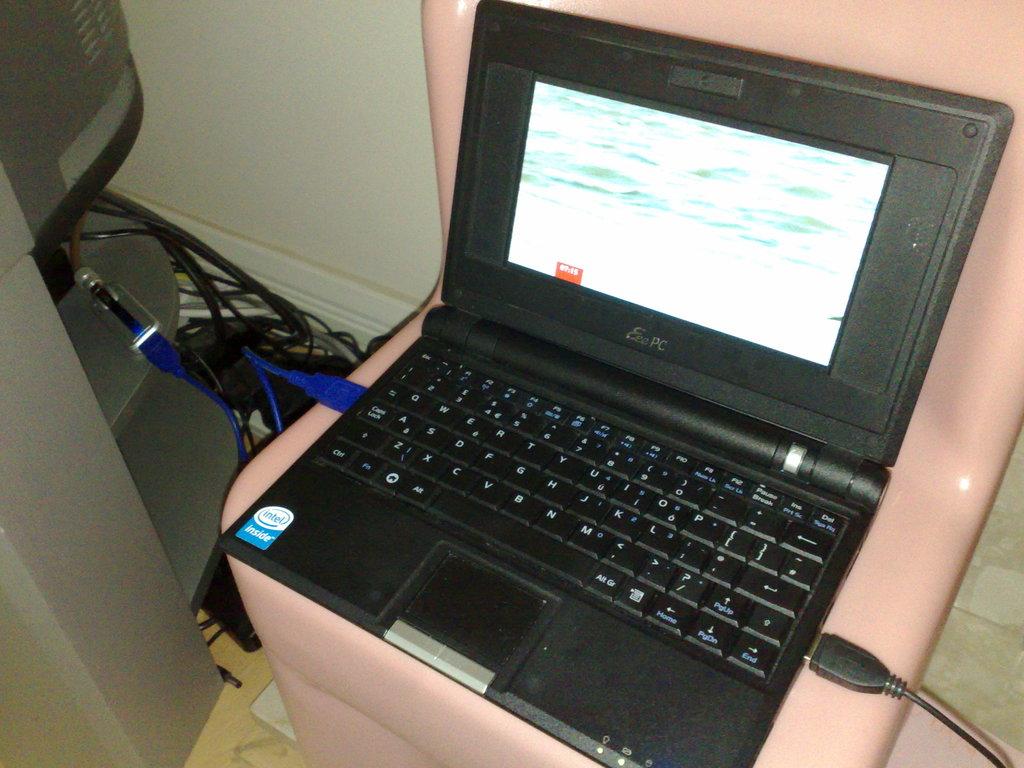What kind of processor does this computer use?
Offer a terse response. Intel. 